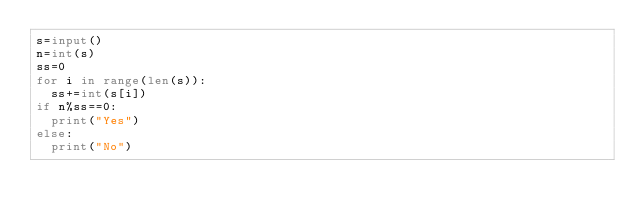Convert code to text. <code><loc_0><loc_0><loc_500><loc_500><_Python_>s=input()
n=int(s)
ss=0
for i in range(len(s)):
  ss+=int(s[i])
if n%ss==0:
  print("Yes")
else:
  print("No")</code> 